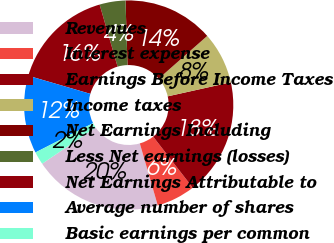Convert chart to OTSL. <chart><loc_0><loc_0><loc_500><loc_500><pie_chart><fcel>Revenues<fcel>Interest expense<fcel>Earnings Before Income Taxes<fcel>Income taxes<fcel>Net Earnings Including<fcel>Less Net earnings (losses)<fcel>Net Earnings Attributable to<fcel>Average number of shares<fcel>Basic earnings per common<nl><fcel>20.0%<fcel>6.0%<fcel>18.0%<fcel>8.0%<fcel>14.0%<fcel>4.0%<fcel>16.0%<fcel>12.0%<fcel>2.0%<nl></chart> 